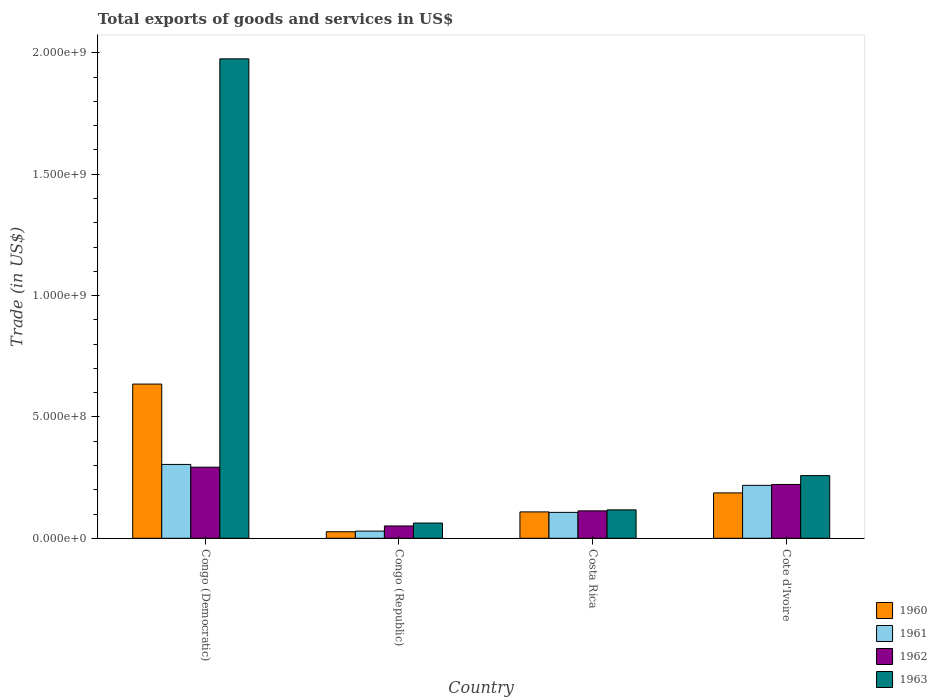In how many cases, is the number of bars for a given country not equal to the number of legend labels?
Your answer should be compact. 0. What is the total exports of goods and services in 1962 in Congo (Republic)?
Offer a terse response. 5.08e+07. Across all countries, what is the maximum total exports of goods and services in 1961?
Your response must be concise. 3.04e+08. Across all countries, what is the minimum total exports of goods and services in 1961?
Provide a short and direct response. 2.95e+07. In which country was the total exports of goods and services in 1962 maximum?
Provide a succinct answer. Congo (Democratic). In which country was the total exports of goods and services in 1962 minimum?
Offer a very short reply. Congo (Republic). What is the total total exports of goods and services in 1962 in the graph?
Give a very brief answer. 6.79e+08. What is the difference between the total exports of goods and services in 1960 in Congo (Democratic) and that in Congo (Republic)?
Make the answer very short. 6.09e+08. What is the difference between the total exports of goods and services in 1960 in Congo (Democratic) and the total exports of goods and services in 1963 in Congo (Republic)?
Make the answer very short. 5.73e+08. What is the average total exports of goods and services in 1963 per country?
Your response must be concise. 6.03e+08. What is the difference between the total exports of goods and services of/in 1960 and total exports of goods and services of/in 1961 in Cote d'Ivoire?
Your response must be concise. -3.12e+07. What is the ratio of the total exports of goods and services in 1961 in Costa Rica to that in Cote d'Ivoire?
Provide a short and direct response. 0.49. Is the difference between the total exports of goods and services in 1960 in Congo (Republic) and Costa Rica greater than the difference between the total exports of goods and services in 1961 in Congo (Republic) and Costa Rica?
Offer a terse response. No. What is the difference between the highest and the second highest total exports of goods and services in 1960?
Ensure brevity in your answer.  7.83e+07. What is the difference between the highest and the lowest total exports of goods and services in 1960?
Ensure brevity in your answer.  6.09e+08. What does the 2nd bar from the right in Cote d'Ivoire represents?
Ensure brevity in your answer.  1962. Is it the case that in every country, the sum of the total exports of goods and services in 1961 and total exports of goods and services in 1963 is greater than the total exports of goods and services in 1960?
Your answer should be compact. Yes. How many countries are there in the graph?
Provide a succinct answer. 4. What is the difference between two consecutive major ticks on the Y-axis?
Offer a very short reply. 5.00e+08. Are the values on the major ticks of Y-axis written in scientific E-notation?
Provide a succinct answer. Yes. Where does the legend appear in the graph?
Offer a very short reply. Bottom right. How many legend labels are there?
Make the answer very short. 4. How are the legend labels stacked?
Provide a short and direct response. Vertical. What is the title of the graph?
Make the answer very short. Total exports of goods and services in US$. What is the label or title of the Y-axis?
Provide a short and direct response. Trade (in US$). What is the Trade (in US$) of 1960 in Congo (Democratic)?
Keep it short and to the point. 6.35e+08. What is the Trade (in US$) in 1961 in Congo (Democratic)?
Your answer should be very brief. 3.04e+08. What is the Trade (in US$) of 1962 in Congo (Democratic)?
Give a very brief answer. 2.93e+08. What is the Trade (in US$) of 1963 in Congo (Democratic)?
Your answer should be very brief. 1.98e+09. What is the Trade (in US$) of 1960 in Congo (Republic)?
Offer a terse response. 2.69e+07. What is the Trade (in US$) in 1961 in Congo (Republic)?
Your answer should be compact. 2.95e+07. What is the Trade (in US$) of 1962 in Congo (Republic)?
Make the answer very short. 5.08e+07. What is the Trade (in US$) in 1963 in Congo (Republic)?
Provide a succinct answer. 6.28e+07. What is the Trade (in US$) in 1960 in Costa Rica?
Provide a succinct answer. 1.09e+08. What is the Trade (in US$) in 1961 in Costa Rica?
Offer a terse response. 1.07e+08. What is the Trade (in US$) in 1962 in Costa Rica?
Provide a succinct answer. 1.13e+08. What is the Trade (in US$) of 1963 in Costa Rica?
Your answer should be compact. 1.17e+08. What is the Trade (in US$) in 1960 in Cote d'Ivoire?
Your response must be concise. 1.87e+08. What is the Trade (in US$) of 1961 in Cote d'Ivoire?
Ensure brevity in your answer.  2.18e+08. What is the Trade (in US$) of 1962 in Cote d'Ivoire?
Offer a very short reply. 2.22e+08. What is the Trade (in US$) in 1963 in Cote d'Ivoire?
Offer a terse response. 2.58e+08. Across all countries, what is the maximum Trade (in US$) in 1960?
Give a very brief answer. 6.35e+08. Across all countries, what is the maximum Trade (in US$) of 1961?
Keep it short and to the point. 3.04e+08. Across all countries, what is the maximum Trade (in US$) in 1962?
Your answer should be compact. 2.93e+08. Across all countries, what is the maximum Trade (in US$) of 1963?
Give a very brief answer. 1.98e+09. Across all countries, what is the minimum Trade (in US$) in 1960?
Offer a very short reply. 2.69e+07. Across all countries, what is the minimum Trade (in US$) in 1961?
Offer a very short reply. 2.95e+07. Across all countries, what is the minimum Trade (in US$) in 1962?
Provide a short and direct response. 5.08e+07. Across all countries, what is the minimum Trade (in US$) of 1963?
Your response must be concise. 6.28e+07. What is the total Trade (in US$) in 1960 in the graph?
Provide a short and direct response. 9.58e+08. What is the total Trade (in US$) of 1961 in the graph?
Keep it short and to the point. 6.59e+08. What is the total Trade (in US$) of 1962 in the graph?
Offer a very short reply. 6.79e+08. What is the total Trade (in US$) in 1963 in the graph?
Your response must be concise. 2.41e+09. What is the difference between the Trade (in US$) of 1960 in Congo (Democratic) and that in Congo (Republic)?
Your response must be concise. 6.09e+08. What is the difference between the Trade (in US$) in 1961 in Congo (Democratic) and that in Congo (Republic)?
Your response must be concise. 2.75e+08. What is the difference between the Trade (in US$) in 1962 in Congo (Democratic) and that in Congo (Republic)?
Keep it short and to the point. 2.42e+08. What is the difference between the Trade (in US$) of 1963 in Congo (Democratic) and that in Congo (Republic)?
Offer a terse response. 1.91e+09. What is the difference between the Trade (in US$) in 1960 in Congo (Democratic) and that in Costa Rica?
Give a very brief answer. 5.27e+08. What is the difference between the Trade (in US$) of 1961 in Congo (Democratic) and that in Costa Rica?
Offer a very short reply. 1.97e+08. What is the difference between the Trade (in US$) of 1962 in Congo (Democratic) and that in Costa Rica?
Ensure brevity in your answer.  1.80e+08. What is the difference between the Trade (in US$) in 1963 in Congo (Democratic) and that in Costa Rica?
Provide a succinct answer. 1.86e+09. What is the difference between the Trade (in US$) in 1960 in Congo (Democratic) and that in Cote d'Ivoire?
Provide a succinct answer. 4.48e+08. What is the difference between the Trade (in US$) of 1961 in Congo (Democratic) and that in Cote d'Ivoire?
Give a very brief answer. 8.61e+07. What is the difference between the Trade (in US$) in 1962 in Congo (Democratic) and that in Cote d'Ivoire?
Ensure brevity in your answer.  7.10e+07. What is the difference between the Trade (in US$) of 1963 in Congo (Democratic) and that in Cote d'Ivoire?
Offer a terse response. 1.72e+09. What is the difference between the Trade (in US$) in 1960 in Congo (Republic) and that in Costa Rica?
Ensure brevity in your answer.  -8.17e+07. What is the difference between the Trade (in US$) of 1961 in Congo (Republic) and that in Costa Rica?
Keep it short and to the point. -7.73e+07. What is the difference between the Trade (in US$) of 1962 in Congo (Republic) and that in Costa Rica?
Provide a succinct answer. -6.23e+07. What is the difference between the Trade (in US$) in 1963 in Congo (Republic) and that in Costa Rica?
Your answer should be compact. -5.43e+07. What is the difference between the Trade (in US$) of 1960 in Congo (Republic) and that in Cote d'Ivoire?
Provide a short and direct response. -1.60e+08. What is the difference between the Trade (in US$) in 1961 in Congo (Republic) and that in Cote d'Ivoire?
Provide a short and direct response. -1.89e+08. What is the difference between the Trade (in US$) in 1962 in Congo (Republic) and that in Cote d'Ivoire?
Keep it short and to the point. -1.71e+08. What is the difference between the Trade (in US$) in 1963 in Congo (Republic) and that in Cote d'Ivoire?
Ensure brevity in your answer.  -1.95e+08. What is the difference between the Trade (in US$) in 1960 in Costa Rica and that in Cote d'Ivoire?
Ensure brevity in your answer.  -7.83e+07. What is the difference between the Trade (in US$) in 1961 in Costa Rica and that in Cote d'Ivoire?
Offer a terse response. -1.11e+08. What is the difference between the Trade (in US$) in 1962 in Costa Rica and that in Cote d'Ivoire?
Offer a terse response. -1.09e+08. What is the difference between the Trade (in US$) of 1963 in Costa Rica and that in Cote d'Ivoire?
Your answer should be compact. -1.41e+08. What is the difference between the Trade (in US$) of 1960 in Congo (Democratic) and the Trade (in US$) of 1961 in Congo (Republic)?
Offer a terse response. 6.06e+08. What is the difference between the Trade (in US$) of 1960 in Congo (Democratic) and the Trade (in US$) of 1962 in Congo (Republic)?
Provide a succinct answer. 5.85e+08. What is the difference between the Trade (in US$) of 1960 in Congo (Democratic) and the Trade (in US$) of 1963 in Congo (Republic)?
Your response must be concise. 5.73e+08. What is the difference between the Trade (in US$) of 1961 in Congo (Democratic) and the Trade (in US$) of 1962 in Congo (Republic)?
Your answer should be very brief. 2.54e+08. What is the difference between the Trade (in US$) of 1961 in Congo (Democratic) and the Trade (in US$) of 1963 in Congo (Republic)?
Your response must be concise. 2.41e+08. What is the difference between the Trade (in US$) of 1962 in Congo (Democratic) and the Trade (in US$) of 1963 in Congo (Republic)?
Your answer should be very brief. 2.30e+08. What is the difference between the Trade (in US$) of 1960 in Congo (Democratic) and the Trade (in US$) of 1961 in Costa Rica?
Offer a very short reply. 5.29e+08. What is the difference between the Trade (in US$) of 1960 in Congo (Democratic) and the Trade (in US$) of 1962 in Costa Rica?
Offer a terse response. 5.22e+08. What is the difference between the Trade (in US$) of 1960 in Congo (Democratic) and the Trade (in US$) of 1963 in Costa Rica?
Your answer should be very brief. 5.18e+08. What is the difference between the Trade (in US$) in 1961 in Congo (Democratic) and the Trade (in US$) in 1962 in Costa Rica?
Give a very brief answer. 1.91e+08. What is the difference between the Trade (in US$) of 1961 in Congo (Democratic) and the Trade (in US$) of 1963 in Costa Rica?
Provide a succinct answer. 1.87e+08. What is the difference between the Trade (in US$) of 1962 in Congo (Democratic) and the Trade (in US$) of 1963 in Costa Rica?
Your answer should be compact. 1.76e+08. What is the difference between the Trade (in US$) in 1960 in Congo (Democratic) and the Trade (in US$) in 1961 in Cote d'Ivoire?
Make the answer very short. 4.17e+08. What is the difference between the Trade (in US$) in 1960 in Congo (Democratic) and the Trade (in US$) in 1962 in Cote d'Ivoire?
Offer a terse response. 4.14e+08. What is the difference between the Trade (in US$) of 1960 in Congo (Democratic) and the Trade (in US$) of 1963 in Cote d'Ivoire?
Your answer should be very brief. 3.77e+08. What is the difference between the Trade (in US$) of 1961 in Congo (Democratic) and the Trade (in US$) of 1962 in Cote d'Ivoire?
Your response must be concise. 8.24e+07. What is the difference between the Trade (in US$) of 1961 in Congo (Democratic) and the Trade (in US$) of 1963 in Cote d'Ivoire?
Ensure brevity in your answer.  4.60e+07. What is the difference between the Trade (in US$) of 1962 in Congo (Democratic) and the Trade (in US$) of 1963 in Cote d'Ivoire?
Ensure brevity in your answer.  3.47e+07. What is the difference between the Trade (in US$) in 1960 in Congo (Republic) and the Trade (in US$) in 1961 in Costa Rica?
Your response must be concise. -7.98e+07. What is the difference between the Trade (in US$) of 1960 in Congo (Republic) and the Trade (in US$) of 1962 in Costa Rica?
Make the answer very short. -8.61e+07. What is the difference between the Trade (in US$) in 1960 in Congo (Republic) and the Trade (in US$) in 1963 in Costa Rica?
Your response must be concise. -9.02e+07. What is the difference between the Trade (in US$) in 1961 in Congo (Republic) and the Trade (in US$) in 1962 in Costa Rica?
Your answer should be compact. -8.35e+07. What is the difference between the Trade (in US$) in 1961 in Congo (Republic) and the Trade (in US$) in 1963 in Costa Rica?
Keep it short and to the point. -8.76e+07. What is the difference between the Trade (in US$) of 1962 in Congo (Republic) and the Trade (in US$) of 1963 in Costa Rica?
Your response must be concise. -6.63e+07. What is the difference between the Trade (in US$) of 1960 in Congo (Republic) and the Trade (in US$) of 1961 in Cote d'Ivoire?
Keep it short and to the point. -1.91e+08. What is the difference between the Trade (in US$) in 1960 in Congo (Republic) and the Trade (in US$) in 1962 in Cote d'Ivoire?
Your response must be concise. -1.95e+08. What is the difference between the Trade (in US$) in 1960 in Congo (Republic) and the Trade (in US$) in 1963 in Cote d'Ivoire?
Offer a terse response. -2.31e+08. What is the difference between the Trade (in US$) of 1961 in Congo (Republic) and the Trade (in US$) of 1962 in Cote d'Ivoire?
Ensure brevity in your answer.  -1.92e+08. What is the difference between the Trade (in US$) in 1961 in Congo (Republic) and the Trade (in US$) in 1963 in Cote d'Ivoire?
Your answer should be very brief. -2.29e+08. What is the difference between the Trade (in US$) of 1962 in Congo (Republic) and the Trade (in US$) of 1963 in Cote d'Ivoire?
Give a very brief answer. -2.07e+08. What is the difference between the Trade (in US$) in 1960 in Costa Rica and the Trade (in US$) in 1961 in Cote d'Ivoire?
Provide a succinct answer. -1.10e+08. What is the difference between the Trade (in US$) of 1960 in Costa Rica and the Trade (in US$) of 1962 in Cote d'Ivoire?
Provide a short and direct response. -1.13e+08. What is the difference between the Trade (in US$) of 1960 in Costa Rica and the Trade (in US$) of 1963 in Cote d'Ivoire?
Give a very brief answer. -1.50e+08. What is the difference between the Trade (in US$) in 1961 in Costa Rica and the Trade (in US$) in 1962 in Cote d'Ivoire?
Give a very brief answer. -1.15e+08. What is the difference between the Trade (in US$) of 1961 in Costa Rica and the Trade (in US$) of 1963 in Cote d'Ivoire?
Ensure brevity in your answer.  -1.51e+08. What is the difference between the Trade (in US$) in 1962 in Costa Rica and the Trade (in US$) in 1963 in Cote d'Ivoire?
Provide a succinct answer. -1.45e+08. What is the average Trade (in US$) in 1960 per country?
Provide a succinct answer. 2.40e+08. What is the average Trade (in US$) in 1961 per country?
Your answer should be very brief. 1.65e+08. What is the average Trade (in US$) in 1962 per country?
Your answer should be compact. 1.70e+08. What is the average Trade (in US$) in 1963 per country?
Provide a short and direct response. 6.03e+08. What is the difference between the Trade (in US$) of 1960 and Trade (in US$) of 1961 in Congo (Democratic)?
Offer a terse response. 3.31e+08. What is the difference between the Trade (in US$) in 1960 and Trade (in US$) in 1962 in Congo (Democratic)?
Your answer should be compact. 3.43e+08. What is the difference between the Trade (in US$) in 1960 and Trade (in US$) in 1963 in Congo (Democratic)?
Your response must be concise. -1.34e+09. What is the difference between the Trade (in US$) in 1961 and Trade (in US$) in 1962 in Congo (Democratic)?
Offer a very short reply. 1.14e+07. What is the difference between the Trade (in US$) in 1961 and Trade (in US$) in 1963 in Congo (Democratic)?
Provide a succinct answer. -1.67e+09. What is the difference between the Trade (in US$) of 1962 and Trade (in US$) of 1963 in Congo (Democratic)?
Ensure brevity in your answer.  -1.68e+09. What is the difference between the Trade (in US$) in 1960 and Trade (in US$) in 1961 in Congo (Republic)?
Give a very brief answer. -2.57e+06. What is the difference between the Trade (in US$) in 1960 and Trade (in US$) in 1962 in Congo (Republic)?
Ensure brevity in your answer.  -2.38e+07. What is the difference between the Trade (in US$) in 1960 and Trade (in US$) in 1963 in Congo (Republic)?
Make the answer very short. -3.59e+07. What is the difference between the Trade (in US$) in 1961 and Trade (in US$) in 1962 in Congo (Republic)?
Ensure brevity in your answer.  -2.13e+07. What is the difference between the Trade (in US$) of 1961 and Trade (in US$) of 1963 in Congo (Republic)?
Give a very brief answer. -3.33e+07. What is the difference between the Trade (in US$) of 1962 and Trade (in US$) of 1963 in Congo (Republic)?
Make the answer very short. -1.20e+07. What is the difference between the Trade (in US$) of 1960 and Trade (in US$) of 1961 in Costa Rica?
Your answer should be very brief. 1.90e+06. What is the difference between the Trade (in US$) in 1960 and Trade (in US$) in 1962 in Costa Rica?
Your answer should be very brief. -4.35e+06. What is the difference between the Trade (in US$) of 1960 and Trade (in US$) of 1963 in Costa Rica?
Make the answer very short. -8.42e+06. What is the difference between the Trade (in US$) in 1961 and Trade (in US$) in 1962 in Costa Rica?
Give a very brief answer. -6.24e+06. What is the difference between the Trade (in US$) of 1961 and Trade (in US$) of 1963 in Costa Rica?
Provide a succinct answer. -1.03e+07. What is the difference between the Trade (in US$) in 1962 and Trade (in US$) in 1963 in Costa Rica?
Offer a very short reply. -4.08e+06. What is the difference between the Trade (in US$) of 1960 and Trade (in US$) of 1961 in Cote d'Ivoire?
Provide a succinct answer. -3.12e+07. What is the difference between the Trade (in US$) in 1960 and Trade (in US$) in 1962 in Cote d'Ivoire?
Provide a succinct answer. -3.49e+07. What is the difference between the Trade (in US$) of 1960 and Trade (in US$) of 1963 in Cote d'Ivoire?
Your response must be concise. -7.12e+07. What is the difference between the Trade (in US$) of 1961 and Trade (in US$) of 1962 in Cote d'Ivoire?
Offer a very short reply. -3.74e+06. What is the difference between the Trade (in US$) of 1961 and Trade (in US$) of 1963 in Cote d'Ivoire?
Give a very brief answer. -4.01e+07. What is the difference between the Trade (in US$) in 1962 and Trade (in US$) in 1963 in Cote d'Ivoire?
Keep it short and to the point. -3.63e+07. What is the ratio of the Trade (in US$) of 1960 in Congo (Democratic) to that in Congo (Republic)?
Offer a very short reply. 23.59. What is the ratio of the Trade (in US$) of 1961 in Congo (Democratic) to that in Congo (Republic)?
Your response must be concise. 10.31. What is the ratio of the Trade (in US$) in 1962 in Congo (Democratic) to that in Congo (Republic)?
Provide a short and direct response. 5.77. What is the ratio of the Trade (in US$) in 1963 in Congo (Democratic) to that in Congo (Republic)?
Provide a succinct answer. 31.45. What is the ratio of the Trade (in US$) of 1960 in Congo (Democratic) to that in Costa Rica?
Give a very brief answer. 5.85. What is the ratio of the Trade (in US$) in 1961 in Congo (Democratic) to that in Costa Rica?
Give a very brief answer. 2.85. What is the ratio of the Trade (in US$) of 1962 in Congo (Democratic) to that in Costa Rica?
Provide a short and direct response. 2.59. What is the ratio of the Trade (in US$) in 1963 in Congo (Democratic) to that in Costa Rica?
Provide a succinct answer. 16.87. What is the ratio of the Trade (in US$) in 1960 in Congo (Democratic) to that in Cote d'Ivoire?
Your response must be concise. 3.4. What is the ratio of the Trade (in US$) in 1961 in Congo (Democratic) to that in Cote d'Ivoire?
Ensure brevity in your answer.  1.39. What is the ratio of the Trade (in US$) of 1962 in Congo (Democratic) to that in Cote d'Ivoire?
Keep it short and to the point. 1.32. What is the ratio of the Trade (in US$) in 1963 in Congo (Democratic) to that in Cote d'Ivoire?
Give a very brief answer. 7.65. What is the ratio of the Trade (in US$) in 1960 in Congo (Republic) to that in Costa Rica?
Provide a succinct answer. 0.25. What is the ratio of the Trade (in US$) of 1961 in Congo (Republic) to that in Costa Rica?
Your answer should be very brief. 0.28. What is the ratio of the Trade (in US$) in 1962 in Congo (Republic) to that in Costa Rica?
Your answer should be compact. 0.45. What is the ratio of the Trade (in US$) of 1963 in Congo (Republic) to that in Costa Rica?
Your answer should be compact. 0.54. What is the ratio of the Trade (in US$) in 1960 in Congo (Republic) to that in Cote d'Ivoire?
Offer a terse response. 0.14. What is the ratio of the Trade (in US$) in 1961 in Congo (Republic) to that in Cote d'Ivoire?
Offer a terse response. 0.14. What is the ratio of the Trade (in US$) of 1962 in Congo (Republic) to that in Cote d'Ivoire?
Your answer should be very brief. 0.23. What is the ratio of the Trade (in US$) of 1963 in Congo (Republic) to that in Cote d'Ivoire?
Offer a very short reply. 0.24. What is the ratio of the Trade (in US$) of 1960 in Costa Rica to that in Cote d'Ivoire?
Offer a very short reply. 0.58. What is the ratio of the Trade (in US$) in 1961 in Costa Rica to that in Cote d'Ivoire?
Give a very brief answer. 0.49. What is the ratio of the Trade (in US$) of 1962 in Costa Rica to that in Cote d'Ivoire?
Offer a terse response. 0.51. What is the ratio of the Trade (in US$) in 1963 in Costa Rica to that in Cote d'Ivoire?
Give a very brief answer. 0.45. What is the difference between the highest and the second highest Trade (in US$) of 1960?
Offer a very short reply. 4.48e+08. What is the difference between the highest and the second highest Trade (in US$) in 1961?
Provide a succinct answer. 8.61e+07. What is the difference between the highest and the second highest Trade (in US$) of 1962?
Provide a short and direct response. 7.10e+07. What is the difference between the highest and the second highest Trade (in US$) in 1963?
Ensure brevity in your answer.  1.72e+09. What is the difference between the highest and the lowest Trade (in US$) in 1960?
Give a very brief answer. 6.09e+08. What is the difference between the highest and the lowest Trade (in US$) in 1961?
Keep it short and to the point. 2.75e+08. What is the difference between the highest and the lowest Trade (in US$) in 1962?
Your answer should be compact. 2.42e+08. What is the difference between the highest and the lowest Trade (in US$) of 1963?
Offer a terse response. 1.91e+09. 